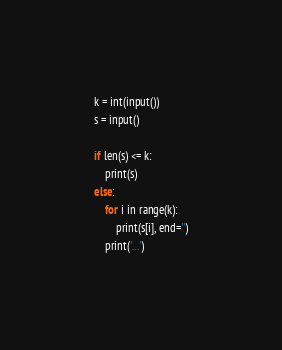Convert code to text. <code><loc_0><loc_0><loc_500><loc_500><_Python_>k = int(input())
s = input()

if len(s) <= k:
	print(s)
else:
	for i in range(k):
		print(s[i], end='')
	print('...')</code> 